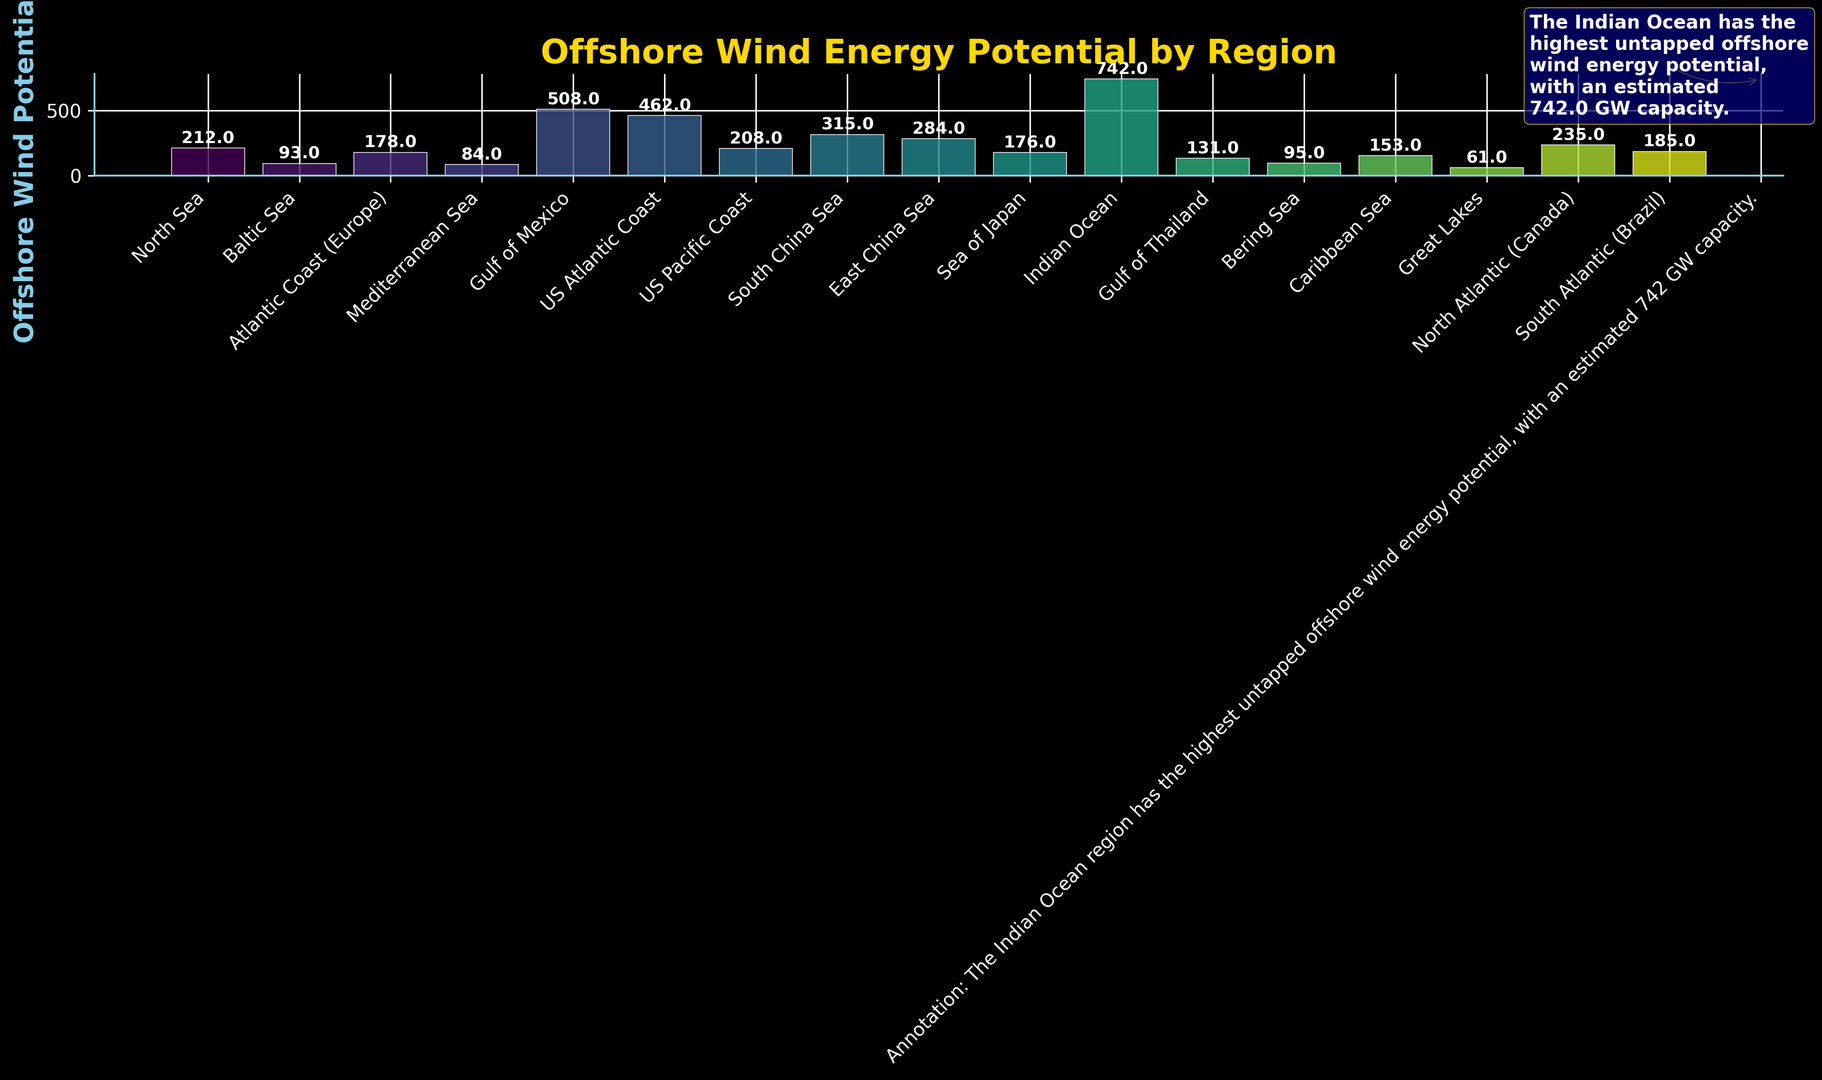What's the offshore wind potential of the Indian Ocean region? Look at the bar labeled "Indian Ocean" and read the value at the top of the bar.
Answer: 742 GW Which region has the highest offshore wind potential? Check all the bars and identify the tallest one, then read the label of that bar.
Answer: Indian Ocean How much greater is the offshore wind potential of the Indian Ocean compared to the North Sea? Locate the bars for the Indian Ocean and North Sea, then subtract the value of North Sea (212 GW) from the value of Indian Ocean (742 GW).
Answer: 530 GW What is the total offshore wind potential of the US regions combined? Sum the values of the US Atlantic Coast (462 GW), US Pacific Coast (208 GW), and Gulf of Mexico (508 GW).
Answer: 1178 GW Among the European regions listed, which has the lowest offshore wind potential? Identify the European regions and find the one with the smallest bar height: North Sea (212 GW), Baltic Sea (93 GW), Atlantic Coast (178 GW), and Mediterranean Sea (84 GW).
Answer: Mediterranean Sea Which region between the East China Sea and South China Sea has a higher offshore wind potential? Compare the heights of the bars representing the East China Sea (284 GW) and South China Sea (315 GW).
Answer: South China Sea What is the average offshore wind potential of the following regions: Caribbean Sea, Gulf of Thailand, and Bering Sea? Add the potentials of Caribbean Sea (153 GW), Gulf of Thailand (131 GW), and Bering Sea (95 GW), then divide by 3.
Answer: 126.33 GW What visual attribute highlights the region with the highest potential in the annotation? Examine the annotation text which specifies that the Indian Ocean has the highest potential, and note that the annotation has a gold arrow pointing to the related bar.
Answer: Gold arrow annotation How does the offshore wind potential of Gulf of Mexico compare with that of the North Atlantic (Canada)? Compare the values on the bars for Gulf of Mexico (508 GW) and North Atlantic (Canada) (235 GW), noting the difference.
Answer: Gulf of Mexico is higher by 273 GW If you combined the offshore wind potentials of the Atlantic coastlines in the US and Europe, what would the total be? Add the offshore wind potentials of the US Atlantic Coast (462 GW) and the Atlantic Coast (Europe) (178 GW).
Answer: 640 GW 